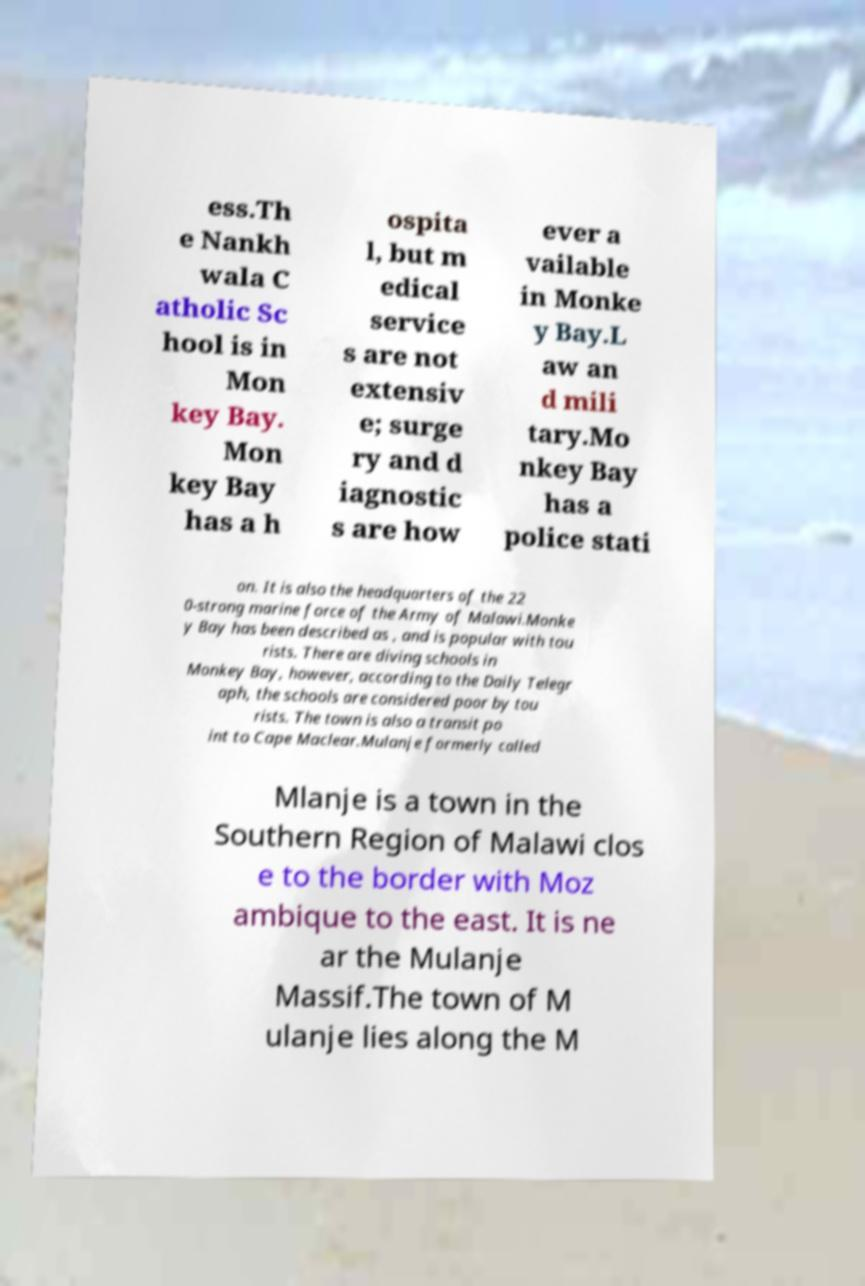Can you read and provide the text displayed in the image?This photo seems to have some interesting text. Can you extract and type it out for me? ess.Th e Nankh wala C atholic Sc hool is in Mon key Bay. Mon key Bay has a h ospita l, but m edical service s are not extensiv e; surge ry and d iagnostic s are how ever a vailable in Monke y Bay.L aw an d mili tary.Mo nkey Bay has a police stati on. It is also the headquarters of the 22 0-strong marine force of the Army of Malawi.Monke y Bay has been described as , and is popular with tou rists. There are diving schools in Monkey Bay, however, according to the Daily Telegr aph, the schools are considered poor by tou rists. The town is also a transit po int to Cape Maclear.Mulanje formerly called Mlanje is a town in the Southern Region of Malawi clos e to the border with Moz ambique to the east. It is ne ar the Mulanje Massif.The town of M ulanje lies along the M 